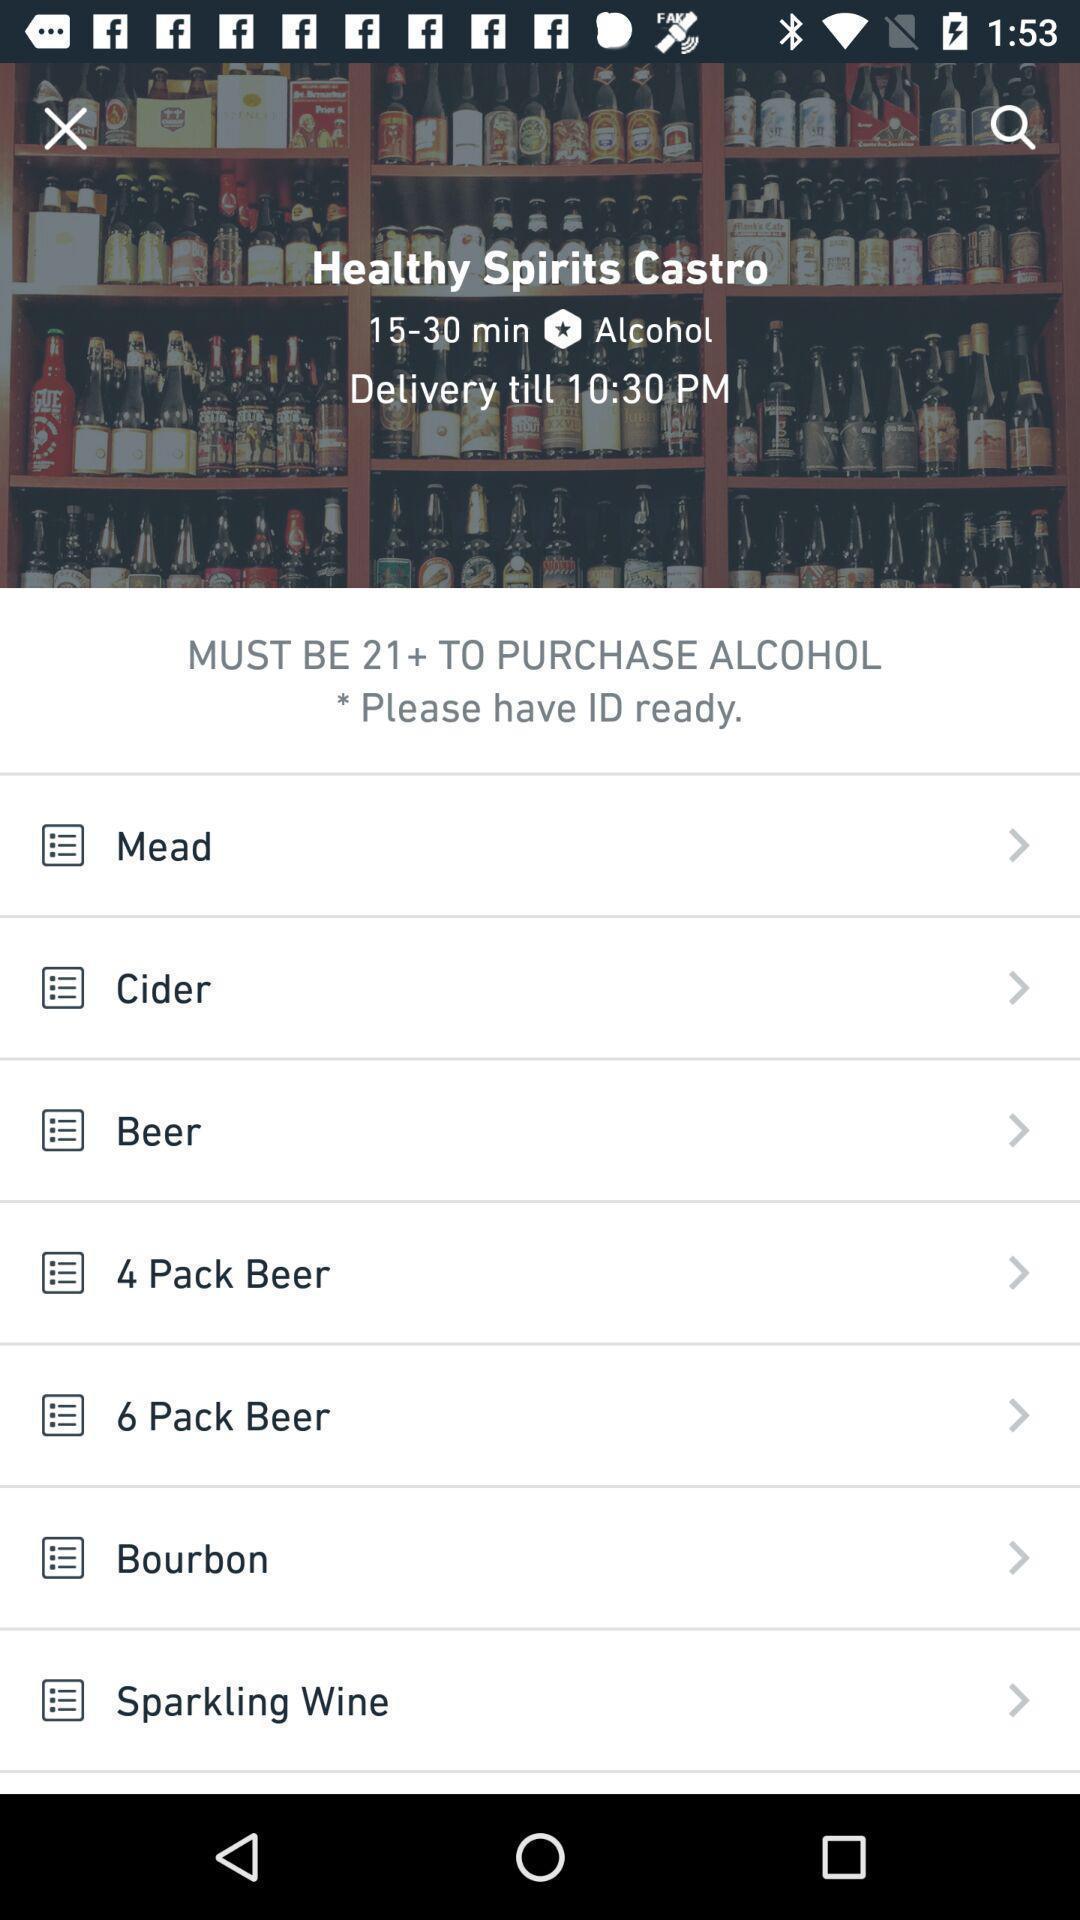Describe the visual elements of this screenshot. Screen display items. 